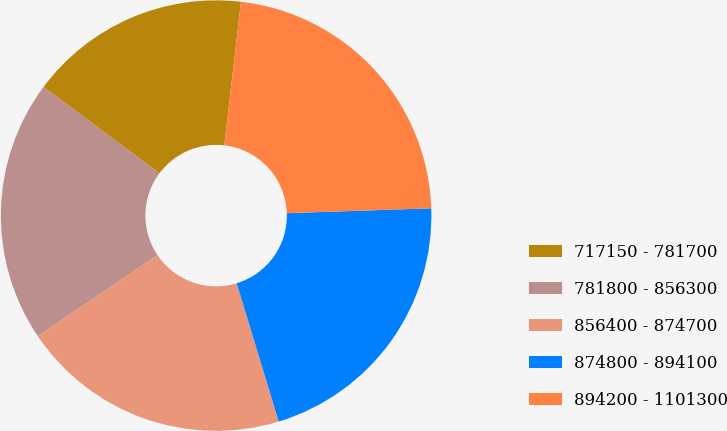<chart> <loc_0><loc_0><loc_500><loc_500><pie_chart><fcel>717150 - 781700<fcel>781800 - 856300<fcel>856400 - 874700<fcel>874800 - 894100<fcel>894200 - 1101300<nl><fcel>16.65%<fcel>19.65%<fcel>20.24%<fcel>20.84%<fcel>22.62%<nl></chart> 